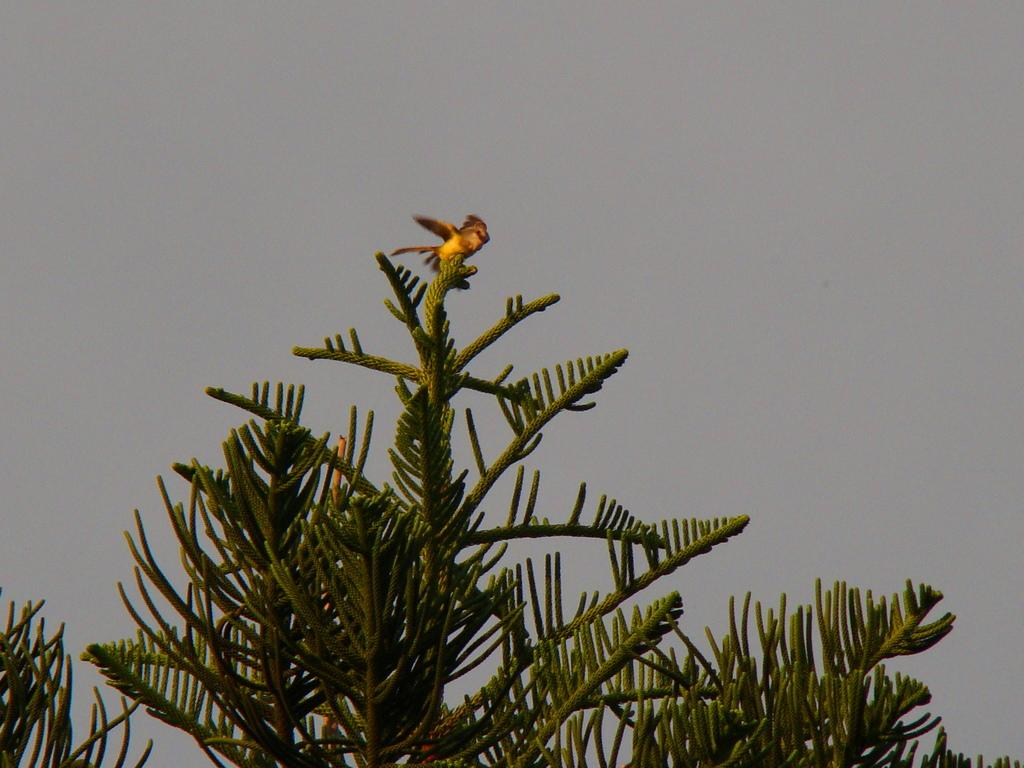What type of animal is in the image? There is a bird in the image. Where is the bird located? The bird is on a tree. What colors can be seen on the bird? The bird has brown and yellow colors. What can be seen in the background of the image? The sky is visible in the background of the image. What type of pollution is visible in the image? There is no pollution visible in the image; it features a bird on a tree with a visible sky in the background. 